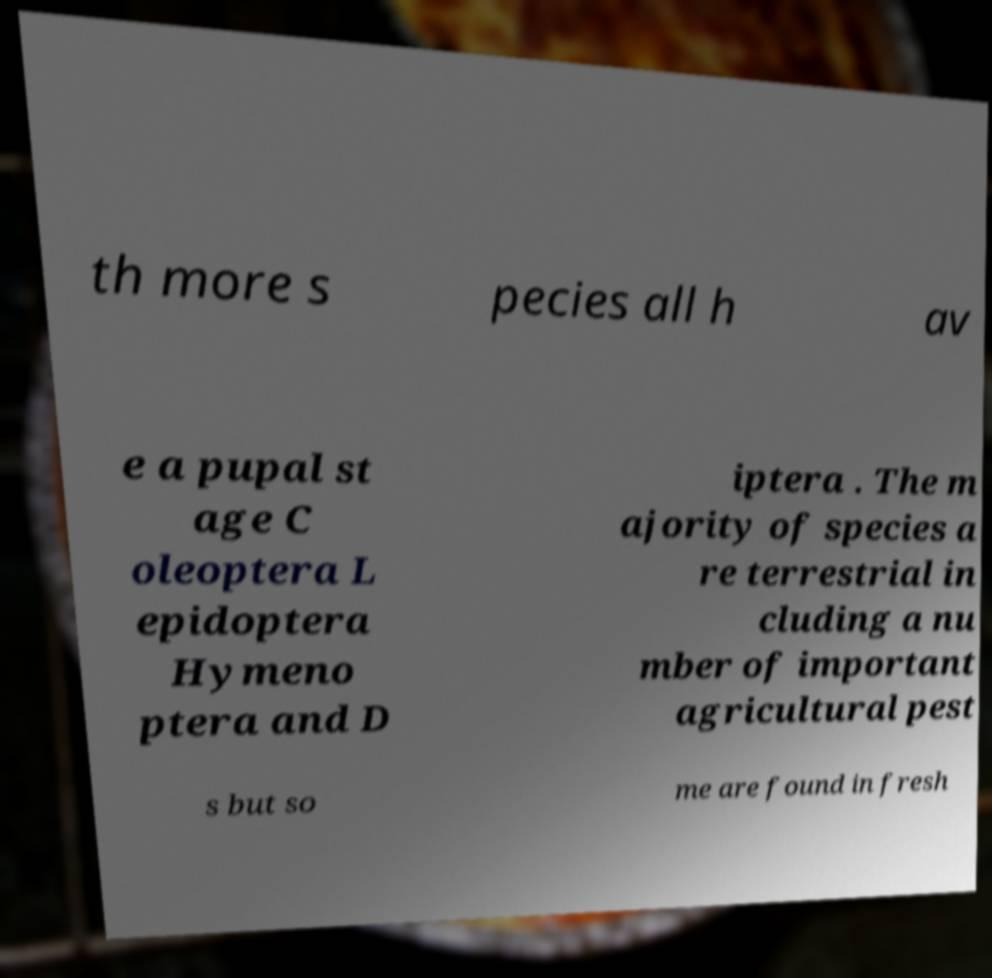Please read and relay the text visible in this image. What does it say? th more s pecies all h av e a pupal st age C oleoptera L epidoptera Hymeno ptera and D iptera . The m ajority of species a re terrestrial in cluding a nu mber of important agricultural pest s but so me are found in fresh 